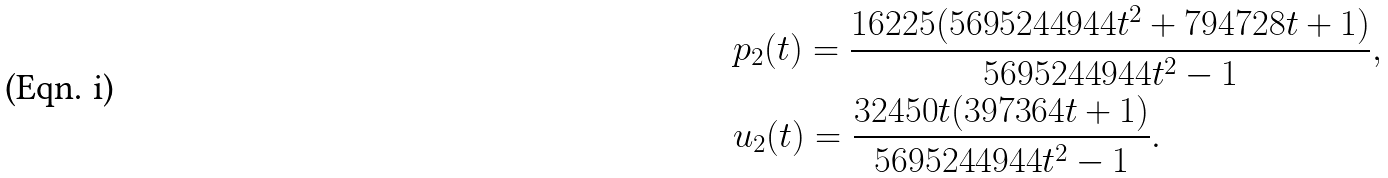<formula> <loc_0><loc_0><loc_500><loc_500>& p _ { 2 } ( t ) = \frac { 1 6 2 2 5 ( 5 6 9 5 2 4 4 9 4 4 t ^ { 2 } + 7 9 4 7 2 8 t + 1 ) } { 5 6 9 5 2 4 4 9 4 4 t ^ { 2 } - 1 } , \\ & u _ { 2 } ( t ) = \frac { 3 2 4 5 0 t ( 3 9 7 3 6 4 t + 1 ) } { 5 6 9 5 2 4 4 9 4 4 t ^ { 2 } - 1 } .</formula> 